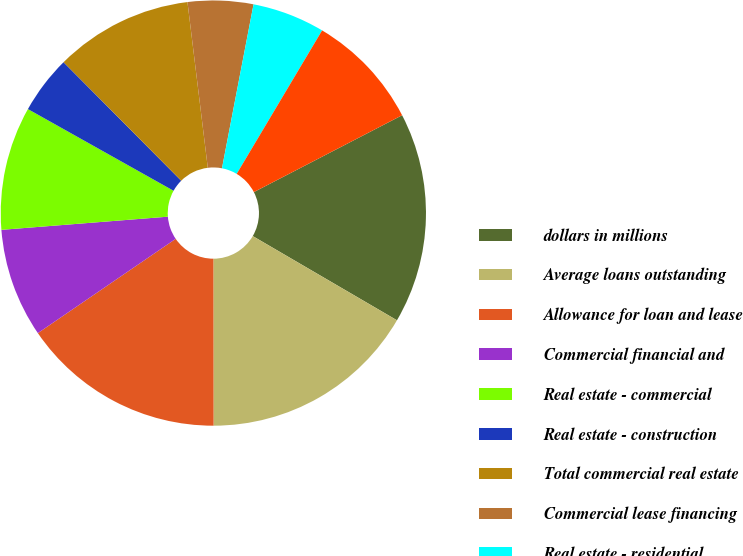Convert chart to OTSL. <chart><loc_0><loc_0><loc_500><loc_500><pie_chart><fcel>dollars in millions<fcel>Average loans outstanding<fcel>Allowance for loan and lease<fcel>Commercial financial and<fcel>Real estate - commercial<fcel>Real estate - construction<fcel>Total commercial real estate<fcel>Commercial lease financing<fcel>Real estate - residential<fcel>Key Community Bank<nl><fcel>16.02%<fcel>16.57%<fcel>15.47%<fcel>8.29%<fcel>9.39%<fcel>4.42%<fcel>10.5%<fcel>4.97%<fcel>5.52%<fcel>8.84%<nl></chart> 